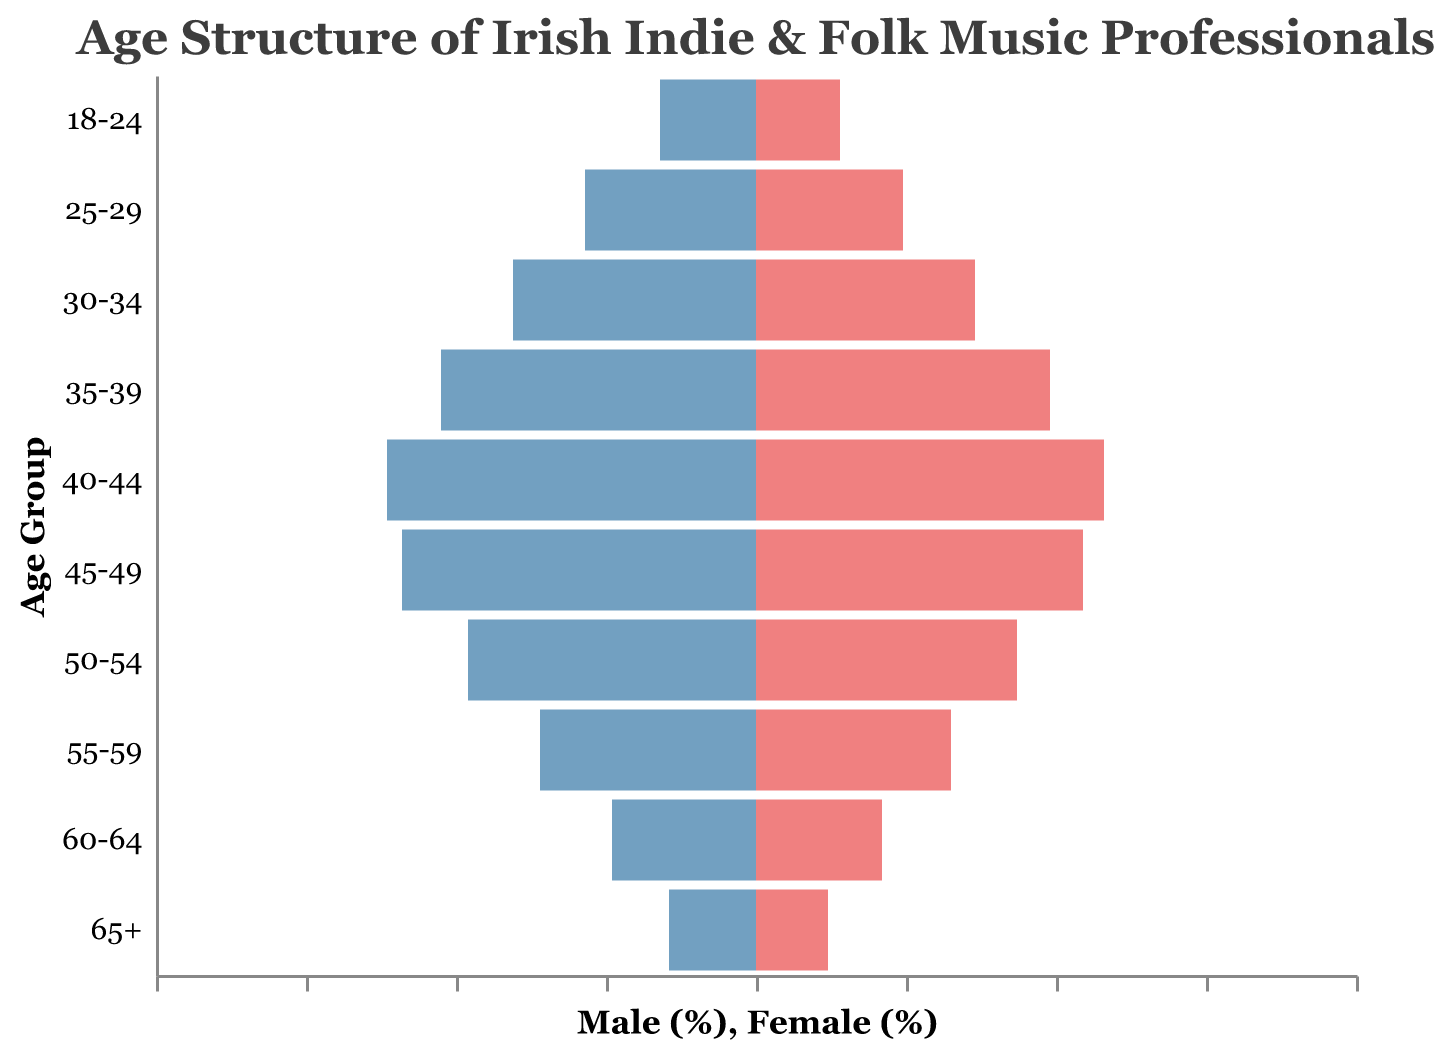What is the color used to represent male professionals in the graph? The bars representing male professionals are colored in blue (specifically a shade like #72A0C1).
Answer: Blue Which age group has the highest percentage of female professionals? The age group 40-44 has the highest percentage of female professionals, with 11.6%.
Answer: 40-44 What is the total percentage of male professionals aged 35-39 and 40-44? The percentage of male professionals aged 35-39 is 10.5%, and for 40-44 it is 12.3%. Adding these together gives 10.5 + 12.3 = 22.8%.
Answer: 22.8% How does the percentage of female professionals aged 45-49 compare to those aged 25-29? The percentage of female professionals aged 45-49 is 10.9%, while for 25-29, it is 4.9%. Therefore, there are 10.9 - 4.9 = 6% more female professionals in the 45-49 age group compared to the 25-29 age group.
Answer: 6% more In which age group is the gender gap (difference between male and female percentages) the smallest? By examining the differences: 18-24 (0.4), 25-29 (0.8), 30-34 (0.8), 35-39 (0.7), 40-44 (0.7), 45-49 (0.9), 50-54 (0.9), 55-59 (0.7), 60-64 (0.6), 65+ (0.5), the smallest gap is in the 18-24 age group with a difference of 0.4.
Answer: 18-24 What is the age group distribution of male professionals aged 30-34 and above? Adding the male percentages from age group 30-34 and older: 8.1 (30-34) + 10.5 (35-39) + 12.3 (40-44) + 11.8 (45-49) + 9.6 (50-54) + 7.2 (55-59) + 4.8 (60-64) + 2.9 (65+) = 67.2%.
Answer: 67.2% Which age group has the most balanced ratio of male to female professionals? The 55-59 age group with male professionals at 7.2% and female professionals at 6.5% has the closest ratio, with a gap of just 0.7%.
Answer: 55-59 What is the percentage difference between male and female professionals aged 60-64? From the figure, the percentage of male professionals aged 60-64 is 4.8%, and for female professionals, it is 4.2%. The difference is 4.8 - 4.2 = 0.6%.
Answer: 0.6% How do the total percentages of male and female professionals compare for those aged 50-54? The percentage of male professionals aged 50-54 is 9.6%, and for female professionals, it is 8.7%. To compare, we observe that 9.6% - 8.7% = 0.9% more male professionals than female professionals.
Answer: 0.9% more 